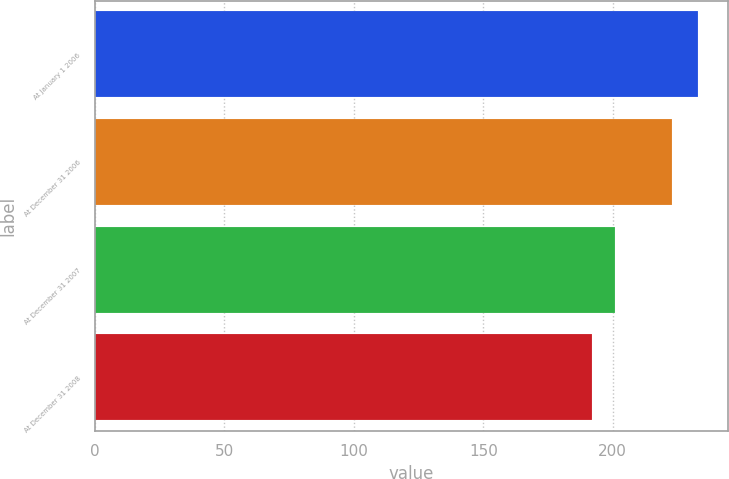Convert chart to OTSL. <chart><loc_0><loc_0><loc_500><loc_500><bar_chart><fcel>At January 1 2006<fcel>At December 31 2006<fcel>At December 31 2007<fcel>At December 31 2008<nl><fcel>233<fcel>223<fcel>201<fcel>192<nl></chart> 